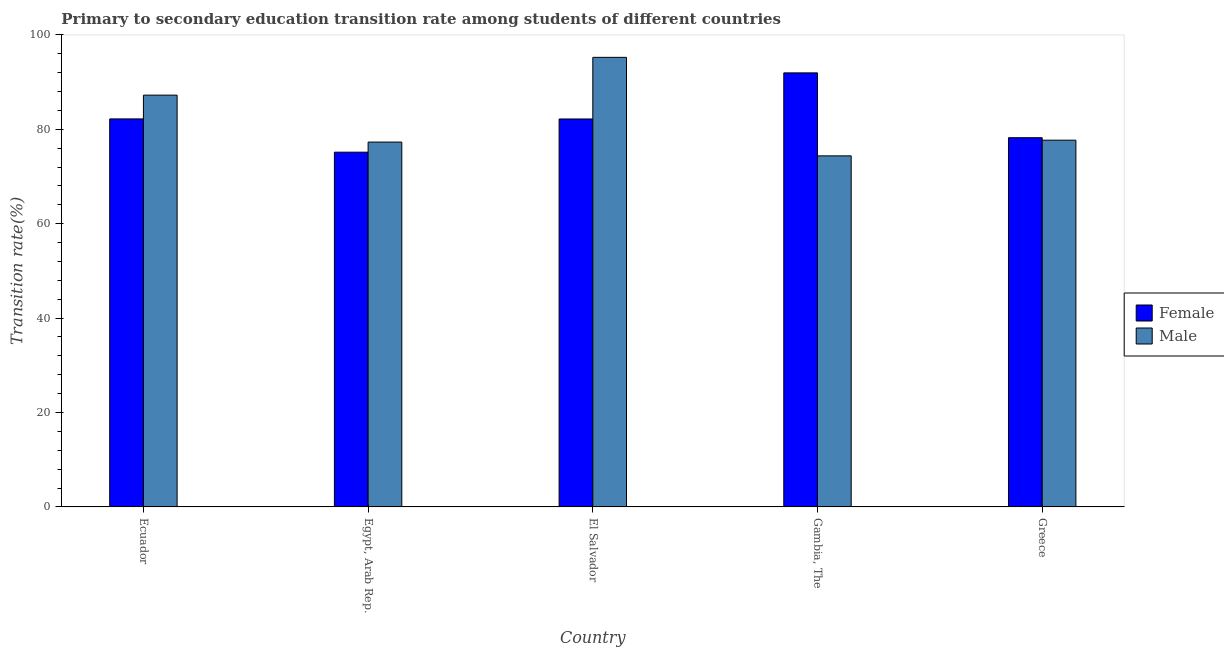How many different coloured bars are there?
Offer a terse response. 2. Are the number of bars per tick equal to the number of legend labels?
Offer a terse response. Yes. How many bars are there on the 2nd tick from the left?
Your answer should be compact. 2. What is the transition rate among male students in Ecuador?
Offer a terse response. 87.24. Across all countries, what is the maximum transition rate among female students?
Your answer should be compact. 91.95. Across all countries, what is the minimum transition rate among male students?
Your response must be concise. 74.37. In which country was the transition rate among female students maximum?
Give a very brief answer. Gambia, The. In which country was the transition rate among female students minimum?
Ensure brevity in your answer.  Egypt, Arab Rep. What is the total transition rate among male students in the graph?
Offer a very short reply. 411.85. What is the difference between the transition rate among male students in El Salvador and that in Greece?
Keep it short and to the point. 17.55. What is the difference between the transition rate among female students in Gambia, The and the transition rate among male students in Egypt, Arab Rep.?
Offer a very short reply. 14.66. What is the average transition rate among male students per country?
Your answer should be compact. 82.37. What is the difference between the transition rate among female students and transition rate among male students in Ecuador?
Your response must be concise. -5.04. In how many countries, is the transition rate among female students greater than 92 %?
Provide a short and direct response. 0. What is the ratio of the transition rate among male students in Ecuador to that in Egypt, Arab Rep.?
Provide a succinct answer. 1.13. Is the transition rate among male students in Ecuador less than that in Egypt, Arab Rep.?
Your answer should be very brief. No. Is the difference between the transition rate among male students in Ecuador and Greece greater than the difference between the transition rate among female students in Ecuador and Greece?
Ensure brevity in your answer.  Yes. What is the difference between the highest and the second highest transition rate among male students?
Keep it short and to the point. 8. What is the difference between the highest and the lowest transition rate among female students?
Keep it short and to the point. 16.8. In how many countries, is the transition rate among female students greater than the average transition rate among female students taken over all countries?
Your answer should be very brief. 3. Is the sum of the transition rate among female students in El Salvador and Gambia, The greater than the maximum transition rate among male students across all countries?
Keep it short and to the point. Yes. What does the 2nd bar from the left in Gambia, The represents?
Ensure brevity in your answer.  Male. Are all the bars in the graph horizontal?
Keep it short and to the point. No. What is the difference between two consecutive major ticks on the Y-axis?
Make the answer very short. 20. Where does the legend appear in the graph?
Offer a very short reply. Center right. How many legend labels are there?
Ensure brevity in your answer.  2. What is the title of the graph?
Offer a terse response. Primary to secondary education transition rate among students of different countries. What is the label or title of the X-axis?
Ensure brevity in your answer.  Country. What is the label or title of the Y-axis?
Your answer should be compact. Transition rate(%). What is the Transition rate(%) of Female in Ecuador?
Offer a very short reply. 82.2. What is the Transition rate(%) in Male in Ecuador?
Your answer should be very brief. 87.24. What is the Transition rate(%) of Female in Egypt, Arab Rep.?
Your response must be concise. 75.15. What is the Transition rate(%) of Male in Egypt, Arab Rep.?
Your response must be concise. 77.3. What is the Transition rate(%) in Female in El Salvador?
Offer a very short reply. 82.19. What is the Transition rate(%) in Male in El Salvador?
Provide a succinct answer. 95.24. What is the Transition rate(%) in Female in Gambia, The?
Make the answer very short. 91.95. What is the Transition rate(%) in Male in Gambia, The?
Give a very brief answer. 74.37. What is the Transition rate(%) in Female in Greece?
Give a very brief answer. 78.22. What is the Transition rate(%) of Male in Greece?
Give a very brief answer. 77.7. Across all countries, what is the maximum Transition rate(%) of Female?
Keep it short and to the point. 91.95. Across all countries, what is the maximum Transition rate(%) in Male?
Give a very brief answer. 95.24. Across all countries, what is the minimum Transition rate(%) in Female?
Your answer should be compact. 75.15. Across all countries, what is the minimum Transition rate(%) in Male?
Ensure brevity in your answer.  74.37. What is the total Transition rate(%) in Female in the graph?
Provide a succinct answer. 409.71. What is the total Transition rate(%) in Male in the graph?
Offer a very short reply. 411.85. What is the difference between the Transition rate(%) in Female in Ecuador and that in Egypt, Arab Rep.?
Give a very brief answer. 7.05. What is the difference between the Transition rate(%) of Male in Ecuador and that in Egypt, Arab Rep.?
Ensure brevity in your answer.  9.94. What is the difference between the Transition rate(%) in Female in Ecuador and that in El Salvador?
Make the answer very short. 0.01. What is the difference between the Transition rate(%) of Male in Ecuador and that in El Salvador?
Your answer should be compact. -8. What is the difference between the Transition rate(%) in Female in Ecuador and that in Gambia, The?
Offer a very short reply. -9.75. What is the difference between the Transition rate(%) of Male in Ecuador and that in Gambia, The?
Offer a very short reply. 12.87. What is the difference between the Transition rate(%) of Female in Ecuador and that in Greece?
Make the answer very short. 3.98. What is the difference between the Transition rate(%) of Male in Ecuador and that in Greece?
Your answer should be very brief. 9.54. What is the difference between the Transition rate(%) of Female in Egypt, Arab Rep. and that in El Salvador?
Keep it short and to the point. -7.03. What is the difference between the Transition rate(%) of Male in Egypt, Arab Rep. and that in El Salvador?
Make the answer very short. -17.95. What is the difference between the Transition rate(%) of Female in Egypt, Arab Rep. and that in Gambia, The?
Give a very brief answer. -16.8. What is the difference between the Transition rate(%) of Male in Egypt, Arab Rep. and that in Gambia, The?
Provide a short and direct response. 2.92. What is the difference between the Transition rate(%) of Female in Egypt, Arab Rep. and that in Greece?
Provide a short and direct response. -3.07. What is the difference between the Transition rate(%) in Male in Egypt, Arab Rep. and that in Greece?
Make the answer very short. -0.4. What is the difference between the Transition rate(%) in Female in El Salvador and that in Gambia, The?
Ensure brevity in your answer.  -9.77. What is the difference between the Transition rate(%) of Male in El Salvador and that in Gambia, The?
Give a very brief answer. 20.87. What is the difference between the Transition rate(%) of Female in El Salvador and that in Greece?
Make the answer very short. 3.97. What is the difference between the Transition rate(%) of Male in El Salvador and that in Greece?
Provide a succinct answer. 17.55. What is the difference between the Transition rate(%) in Female in Gambia, The and that in Greece?
Give a very brief answer. 13.73. What is the difference between the Transition rate(%) of Male in Gambia, The and that in Greece?
Ensure brevity in your answer.  -3.32. What is the difference between the Transition rate(%) in Female in Ecuador and the Transition rate(%) in Male in Egypt, Arab Rep.?
Your answer should be very brief. 4.91. What is the difference between the Transition rate(%) in Female in Ecuador and the Transition rate(%) in Male in El Salvador?
Offer a terse response. -13.04. What is the difference between the Transition rate(%) in Female in Ecuador and the Transition rate(%) in Male in Gambia, The?
Your answer should be very brief. 7.83. What is the difference between the Transition rate(%) in Female in Ecuador and the Transition rate(%) in Male in Greece?
Your answer should be compact. 4.5. What is the difference between the Transition rate(%) in Female in Egypt, Arab Rep. and the Transition rate(%) in Male in El Salvador?
Offer a very short reply. -20.09. What is the difference between the Transition rate(%) in Female in Egypt, Arab Rep. and the Transition rate(%) in Male in Gambia, The?
Offer a terse response. 0.78. What is the difference between the Transition rate(%) of Female in Egypt, Arab Rep. and the Transition rate(%) of Male in Greece?
Keep it short and to the point. -2.54. What is the difference between the Transition rate(%) of Female in El Salvador and the Transition rate(%) of Male in Gambia, The?
Offer a terse response. 7.81. What is the difference between the Transition rate(%) in Female in El Salvador and the Transition rate(%) in Male in Greece?
Make the answer very short. 4.49. What is the difference between the Transition rate(%) in Female in Gambia, The and the Transition rate(%) in Male in Greece?
Your answer should be compact. 14.26. What is the average Transition rate(%) in Female per country?
Your response must be concise. 81.94. What is the average Transition rate(%) in Male per country?
Give a very brief answer. 82.37. What is the difference between the Transition rate(%) in Female and Transition rate(%) in Male in Ecuador?
Make the answer very short. -5.04. What is the difference between the Transition rate(%) in Female and Transition rate(%) in Male in Egypt, Arab Rep.?
Offer a terse response. -2.14. What is the difference between the Transition rate(%) in Female and Transition rate(%) in Male in El Salvador?
Provide a succinct answer. -13.06. What is the difference between the Transition rate(%) of Female and Transition rate(%) of Male in Gambia, The?
Give a very brief answer. 17.58. What is the difference between the Transition rate(%) in Female and Transition rate(%) in Male in Greece?
Make the answer very short. 0.52. What is the ratio of the Transition rate(%) of Female in Ecuador to that in Egypt, Arab Rep.?
Provide a succinct answer. 1.09. What is the ratio of the Transition rate(%) of Male in Ecuador to that in Egypt, Arab Rep.?
Your answer should be very brief. 1.13. What is the ratio of the Transition rate(%) in Female in Ecuador to that in El Salvador?
Make the answer very short. 1. What is the ratio of the Transition rate(%) in Male in Ecuador to that in El Salvador?
Your answer should be very brief. 0.92. What is the ratio of the Transition rate(%) of Female in Ecuador to that in Gambia, The?
Provide a short and direct response. 0.89. What is the ratio of the Transition rate(%) in Male in Ecuador to that in Gambia, The?
Give a very brief answer. 1.17. What is the ratio of the Transition rate(%) in Female in Ecuador to that in Greece?
Your answer should be compact. 1.05. What is the ratio of the Transition rate(%) in Male in Ecuador to that in Greece?
Offer a very short reply. 1.12. What is the ratio of the Transition rate(%) in Female in Egypt, Arab Rep. to that in El Salvador?
Keep it short and to the point. 0.91. What is the ratio of the Transition rate(%) of Male in Egypt, Arab Rep. to that in El Salvador?
Offer a very short reply. 0.81. What is the ratio of the Transition rate(%) of Female in Egypt, Arab Rep. to that in Gambia, The?
Give a very brief answer. 0.82. What is the ratio of the Transition rate(%) in Male in Egypt, Arab Rep. to that in Gambia, The?
Ensure brevity in your answer.  1.04. What is the ratio of the Transition rate(%) in Female in Egypt, Arab Rep. to that in Greece?
Your answer should be very brief. 0.96. What is the ratio of the Transition rate(%) of Female in El Salvador to that in Gambia, The?
Ensure brevity in your answer.  0.89. What is the ratio of the Transition rate(%) in Male in El Salvador to that in Gambia, The?
Offer a very short reply. 1.28. What is the ratio of the Transition rate(%) of Female in El Salvador to that in Greece?
Offer a terse response. 1.05. What is the ratio of the Transition rate(%) of Male in El Salvador to that in Greece?
Provide a succinct answer. 1.23. What is the ratio of the Transition rate(%) of Female in Gambia, The to that in Greece?
Make the answer very short. 1.18. What is the ratio of the Transition rate(%) in Male in Gambia, The to that in Greece?
Give a very brief answer. 0.96. What is the difference between the highest and the second highest Transition rate(%) of Female?
Provide a succinct answer. 9.75. What is the difference between the highest and the second highest Transition rate(%) of Male?
Offer a terse response. 8. What is the difference between the highest and the lowest Transition rate(%) of Female?
Offer a very short reply. 16.8. What is the difference between the highest and the lowest Transition rate(%) of Male?
Make the answer very short. 20.87. 